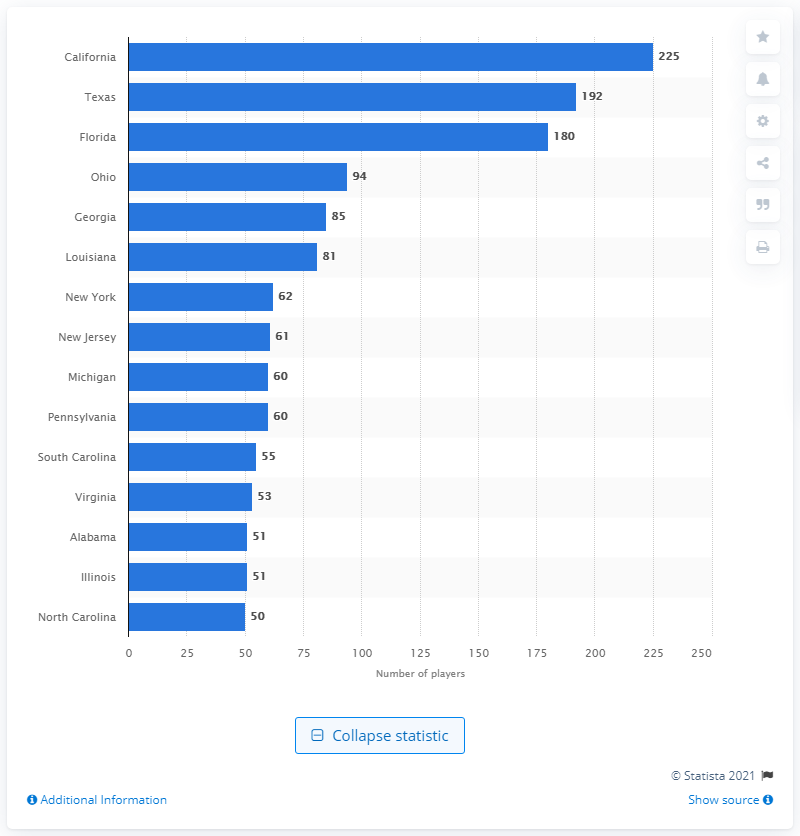Draw attention to some important aspects in this diagram. According to my information, 225 current NFL players were born in the state of California. 